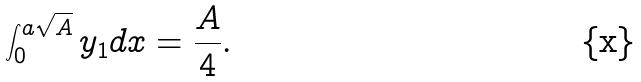Convert formula to latex. <formula><loc_0><loc_0><loc_500><loc_500>\int _ { 0 } ^ { a \sqrt { A } } y _ { 1 } d x = \frac { A } { 4 } .</formula> 